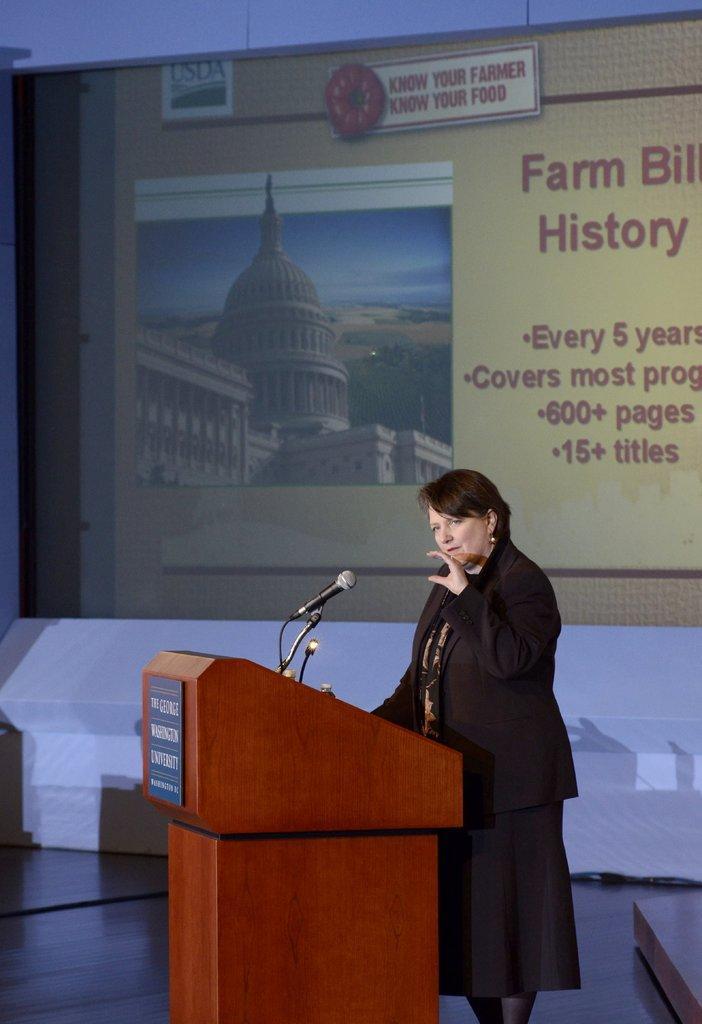Can you describe this image briefly? In this picture we can see a woman wearing black suit, standing at the speech desk and giving a speech. Behind there is a projector screen. 